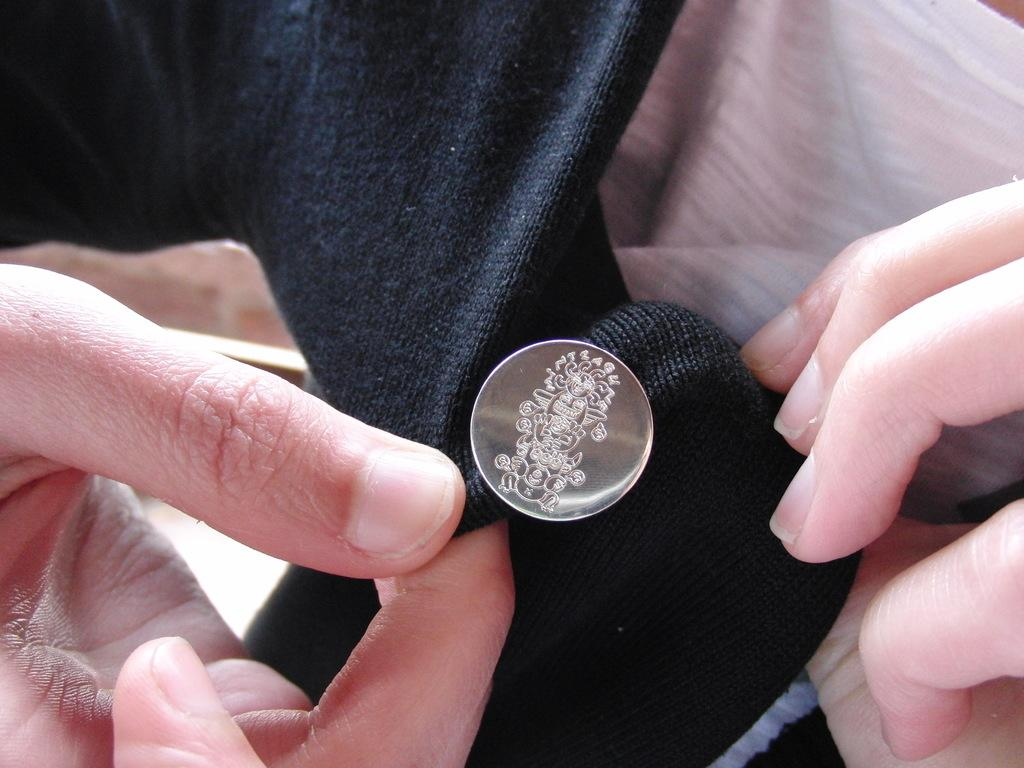Who or what is present in the image? There is a person in the image. What is the person holding in the image? The person is holding a cloth in the image. What is on the cloth that the person is holding? There is a dollar on the cloth. What color scheme is used for the cloth in the image? The cloth is in black and white color. What type of thunder can be heard in the image? There is no thunder present in the image, as it is a still image and does not contain any sound. 